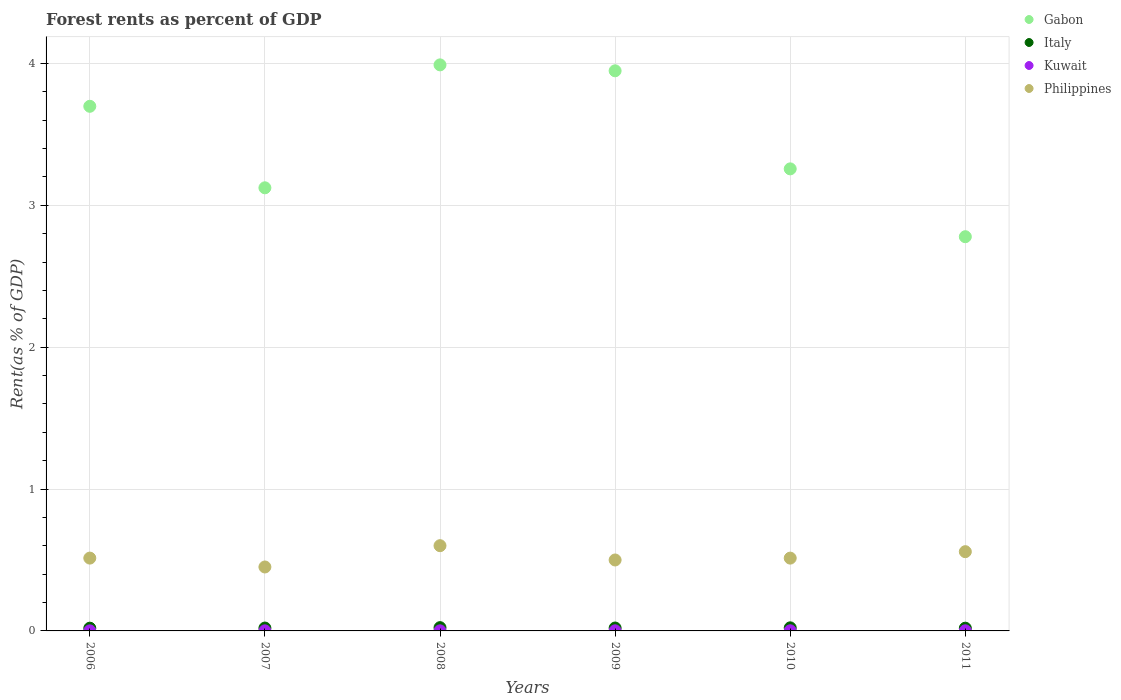Is the number of dotlines equal to the number of legend labels?
Offer a very short reply. Yes. What is the forest rent in Italy in 2010?
Keep it short and to the point. 0.02. Across all years, what is the maximum forest rent in Philippines?
Provide a succinct answer. 0.6. Across all years, what is the minimum forest rent in Kuwait?
Your answer should be compact. 0. What is the total forest rent in Italy in the graph?
Give a very brief answer. 0.12. What is the difference between the forest rent in Gabon in 2008 and that in 2010?
Your answer should be very brief. 0.73. What is the difference between the forest rent in Philippines in 2010 and the forest rent in Italy in 2009?
Offer a very short reply. 0.49. What is the average forest rent in Italy per year?
Provide a succinct answer. 0.02. In the year 2006, what is the difference between the forest rent in Kuwait and forest rent in Philippines?
Offer a very short reply. -0.51. In how many years, is the forest rent in Italy greater than 3 %?
Make the answer very short. 0. What is the ratio of the forest rent in Italy in 2007 to that in 2009?
Ensure brevity in your answer.  0.99. Is the forest rent in Italy in 2006 less than that in 2009?
Give a very brief answer. Yes. Is the difference between the forest rent in Kuwait in 2006 and 2008 greater than the difference between the forest rent in Philippines in 2006 and 2008?
Give a very brief answer. Yes. What is the difference between the highest and the second highest forest rent in Kuwait?
Provide a short and direct response. 0. What is the difference between the highest and the lowest forest rent in Kuwait?
Your answer should be compact. 0. In how many years, is the forest rent in Kuwait greater than the average forest rent in Kuwait taken over all years?
Offer a terse response. 3. Is it the case that in every year, the sum of the forest rent in Philippines and forest rent in Kuwait  is greater than the forest rent in Italy?
Offer a terse response. Yes. How many dotlines are there?
Your response must be concise. 4. What is the title of the graph?
Provide a short and direct response. Forest rents as percent of GDP. Does "Seychelles" appear as one of the legend labels in the graph?
Provide a succinct answer. No. What is the label or title of the X-axis?
Give a very brief answer. Years. What is the label or title of the Y-axis?
Your answer should be very brief. Rent(as % of GDP). What is the Rent(as % of GDP) in Gabon in 2006?
Offer a terse response. 3.7. What is the Rent(as % of GDP) of Italy in 2006?
Give a very brief answer. 0.02. What is the Rent(as % of GDP) in Kuwait in 2006?
Your answer should be very brief. 0. What is the Rent(as % of GDP) of Philippines in 2006?
Keep it short and to the point. 0.51. What is the Rent(as % of GDP) of Gabon in 2007?
Give a very brief answer. 3.12. What is the Rent(as % of GDP) of Italy in 2007?
Keep it short and to the point. 0.02. What is the Rent(as % of GDP) of Kuwait in 2007?
Give a very brief answer. 0. What is the Rent(as % of GDP) of Philippines in 2007?
Offer a very short reply. 0.45. What is the Rent(as % of GDP) in Gabon in 2008?
Offer a very short reply. 3.99. What is the Rent(as % of GDP) of Italy in 2008?
Ensure brevity in your answer.  0.02. What is the Rent(as % of GDP) of Kuwait in 2008?
Your answer should be compact. 0. What is the Rent(as % of GDP) of Philippines in 2008?
Your answer should be compact. 0.6. What is the Rent(as % of GDP) of Gabon in 2009?
Provide a succinct answer. 3.95. What is the Rent(as % of GDP) in Italy in 2009?
Offer a very short reply. 0.02. What is the Rent(as % of GDP) in Kuwait in 2009?
Offer a terse response. 0. What is the Rent(as % of GDP) in Philippines in 2009?
Your answer should be compact. 0.5. What is the Rent(as % of GDP) of Gabon in 2010?
Your answer should be compact. 3.26. What is the Rent(as % of GDP) of Italy in 2010?
Make the answer very short. 0.02. What is the Rent(as % of GDP) in Kuwait in 2010?
Provide a succinct answer. 0. What is the Rent(as % of GDP) of Philippines in 2010?
Ensure brevity in your answer.  0.51. What is the Rent(as % of GDP) in Gabon in 2011?
Provide a short and direct response. 2.78. What is the Rent(as % of GDP) of Italy in 2011?
Keep it short and to the point. 0.02. What is the Rent(as % of GDP) of Kuwait in 2011?
Your answer should be compact. 0. What is the Rent(as % of GDP) of Philippines in 2011?
Provide a succinct answer. 0.56. Across all years, what is the maximum Rent(as % of GDP) of Gabon?
Offer a very short reply. 3.99. Across all years, what is the maximum Rent(as % of GDP) in Italy?
Offer a terse response. 0.02. Across all years, what is the maximum Rent(as % of GDP) in Kuwait?
Your response must be concise. 0. Across all years, what is the maximum Rent(as % of GDP) of Philippines?
Your response must be concise. 0.6. Across all years, what is the minimum Rent(as % of GDP) of Gabon?
Your response must be concise. 2.78. Across all years, what is the minimum Rent(as % of GDP) in Italy?
Provide a succinct answer. 0.02. Across all years, what is the minimum Rent(as % of GDP) in Kuwait?
Offer a very short reply. 0. Across all years, what is the minimum Rent(as % of GDP) of Philippines?
Offer a very short reply. 0.45. What is the total Rent(as % of GDP) in Gabon in the graph?
Keep it short and to the point. 20.8. What is the total Rent(as % of GDP) in Italy in the graph?
Make the answer very short. 0.12. What is the total Rent(as % of GDP) of Kuwait in the graph?
Your answer should be very brief. 0. What is the total Rent(as % of GDP) in Philippines in the graph?
Your answer should be very brief. 3.14. What is the difference between the Rent(as % of GDP) in Gabon in 2006 and that in 2007?
Give a very brief answer. 0.57. What is the difference between the Rent(as % of GDP) in Italy in 2006 and that in 2007?
Provide a short and direct response. -0. What is the difference between the Rent(as % of GDP) in Kuwait in 2006 and that in 2007?
Your answer should be very brief. -0. What is the difference between the Rent(as % of GDP) of Philippines in 2006 and that in 2007?
Provide a succinct answer. 0.06. What is the difference between the Rent(as % of GDP) of Gabon in 2006 and that in 2008?
Make the answer very short. -0.29. What is the difference between the Rent(as % of GDP) of Italy in 2006 and that in 2008?
Make the answer very short. -0. What is the difference between the Rent(as % of GDP) of Kuwait in 2006 and that in 2008?
Offer a very short reply. -0. What is the difference between the Rent(as % of GDP) of Philippines in 2006 and that in 2008?
Your answer should be very brief. -0.09. What is the difference between the Rent(as % of GDP) in Gabon in 2006 and that in 2009?
Provide a short and direct response. -0.25. What is the difference between the Rent(as % of GDP) in Italy in 2006 and that in 2009?
Provide a succinct answer. -0. What is the difference between the Rent(as % of GDP) of Kuwait in 2006 and that in 2009?
Your answer should be compact. -0. What is the difference between the Rent(as % of GDP) of Philippines in 2006 and that in 2009?
Keep it short and to the point. 0.01. What is the difference between the Rent(as % of GDP) in Gabon in 2006 and that in 2010?
Make the answer very short. 0.44. What is the difference between the Rent(as % of GDP) of Italy in 2006 and that in 2010?
Offer a very short reply. -0. What is the difference between the Rent(as % of GDP) of Kuwait in 2006 and that in 2010?
Provide a short and direct response. -0. What is the difference between the Rent(as % of GDP) in Gabon in 2006 and that in 2011?
Ensure brevity in your answer.  0.92. What is the difference between the Rent(as % of GDP) in Kuwait in 2006 and that in 2011?
Offer a terse response. -0. What is the difference between the Rent(as % of GDP) in Philippines in 2006 and that in 2011?
Give a very brief answer. -0.05. What is the difference between the Rent(as % of GDP) in Gabon in 2007 and that in 2008?
Offer a terse response. -0.87. What is the difference between the Rent(as % of GDP) of Italy in 2007 and that in 2008?
Keep it short and to the point. -0. What is the difference between the Rent(as % of GDP) of Philippines in 2007 and that in 2008?
Your response must be concise. -0.15. What is the difference between the Rent(as % of GDP) in Gabon in 2007 and that in 2009?
Provide a short and direct response. -0.82. What is the difference between the Rent(as % of GDP) in Italy in 2007 and that in 2009?
Provide a short and direct response. -0. What is the difference between the Rent(as % of GDP) in Kuwait in 2007 and that in 2009?
Offer a very short reply. -0. What is the difference between the Rent(as % of GDP) of Philippines in 2007 and that in 2009?
Provide a succinct answer. -0.05. What is the difference between the Rent(as % of GDP) of Gabon in 2007 and that in 2010?
Keep it short and to the point. -0.13. What is the difference between the Rent(as % of GDP) of Italy in 2007 and that in 2010?
Provide a succinct answer. -0. What is the difference between the Rent(as % of GDP) of Kuwait in 2007 and that in 2010?
Your answer should be compact. -0. What is the difference between the Rent(as % of GDP) of Philippines in 2007 and that in 2010?
Your answer should be compact. -0.06. What is the difference between the Rent(as % of GDP) in Gabon in 2007 and that in 2011?
Your response must be concise. 0.34. What is the difference between the Rent(as % of GDP) of Italy in 2007 and that in 2011?
Ensure brevity in your answer.  0. What is the difference between the Rent(as % of GDP) of Kuwait in 2007 and that in 2011?
Make the answer very short. -0. What is the difference between the Rent(as % of GDP) of Philippines in 2007 and that in 2011?
Ensure brevity in your answer.  -0.11. What is the difference between the Rent(as % of GDP) of Gabon in 2008 and that in 2009?
Your response must be concise. 0.04. What is the difference between the Rent(as % of GDP) of Italy in 2008 and that in 2009?
Make the answer very short. 0. What is the difference between the Rent(as % of GDP) of Kuwait in 2008 and that in 2009?
Offer a terse response. -0. What is the difference between the Rent(as % of GDP) in Philippines in 2008 and that in 2009?
Your response must be concise. 0.1. What is the difference between the Rent(as % of GDP) of Gabon in 2008 and that in 2010?
Keep it short and to the point. 0.73. What is the difference between the Rent(as % of GDP) in Italy in 2008 and that in 2010?
Give a very brief answer. 0. What is the difference between the Rent(as % of GDP) of Kuwait in 2008 and that in 2010?
Your answer should be very brief. -0. What is the difference between the Rent(as % of GDP) in Philippines in 2008 and that in 2010?
Give a very brief answer. 0.09. What is the difference between the Rent(as % of GDP) in Gabon in 2008 and that in 2011?
Keep it short and to the point. 1.21. What is the difference between the Rent(as % of GDP) in Italy in 2008 and that in 2011?
Your answer should be very brief. 0. What is the difference between the Rent(as % of GDP) in Kuwait in 2008 and that in 2011?
Offer a very short reply. -0. What is the difference between the Rent(as % of GDP) of Philippines in 2008 and that in 2011?
Ensure brevity in your answer.  0.04. What is the difference between the Rent(as % of GDP) in Gabon in 2009 and that in 2010?
Keep it short and to the point. 0.69. What is the difference between the Rent(as % of GDP) in Italy in 2009 and that in 2010?
Your response must be concise. -0. What is the difference between the Rent(as % of GDP) of Kuwait in 2009 and that in 2010?
Offer a terse response. -0. What is the difference between the Rent(as % of GDP) of Philippines in 2009 and that in 2010?
Keep it short and to the point. -0.01. What is the difference between the Rent(as % of GDP) in Gabon in 2009 and that in 2011?
Your response must be concise. 1.17. What is the difference between the Rent(as % of GDP) in Italy in 2009 and that in 2011?
Offer a terse response. 0. What is the difference between the Rent(as % of GDP) in Philippines in 2009 and that in 2011?
Provide a succinct answer. -0.06. What is the difference between the Rent(as % of GDP) in Gabon in 2010 and that in 2011?
Give a very brief answer. 0.48. What is the difference between the Rent(as % of GDP) in Italy in 2010 and that in 2011?
Provide a short and direct response. 0. What is the difference between the Rent(as % of GDP) of Kuwait in 2010 and that in 2011?
Keep it short and to the point. 0. What is the difference between the Rent(as % of GDP) of Philippines in 2010 and that in 2011?
Ensure brevity in your answer.  -0.05. What is the difference between the Rent(as % of GDP) of Gabon in 2006 and the Rent(as % of GDP) of Italy in 2007?
Your response must be concise. 3.68. What is the difference between the Rent(as % of GDP) in Gabon in 2006 and the Rent(as % of GDP) in Kuwait in 2007?
Provide a short and direct response. 3.7. What is the difference between the Rent(as % of GDP) of Gabon in 2006 and the Rent(as % of GDP) of Philippines in 2007?
Your answer should be compact. 3.25. What is the difference between the Rent(as % of GDP) of Italy in 2006 and the Rent(as % of GDP) of Kuwait in 2007?
Provide a short and direct response. 0.02. What is the difference between the Rent(as % of GDP) of Italy in 2006 and the Rent(as % of GDP) of Philippines in 2007?
Offer a terse response. -0.43. What is the difference between the Rent(as % of GDP) of Kuwait in 2006 and the Rent(as % of GDP) of Philippines in 2007?
Your answer should be very brief. -0.45. What is the difference between the Rent(as % of GDP) in Gabon in 2006 and the Rent(as % of GDP) in Italy in 2008?
Provide a short and direct response. 3.68. What is the difference between the Rent(as % of GDP) in Gabon in 2006 and the Rent(as % of GDP) in Kuwait in 2008?
Offer a very short reply. 3.7. What is the difference between the Rent(as % of GDP) in Gabon in 2006 and the Rent(as % of GDP) in Philippines in 2008?
Offer a terse response. 3.1. What is the difference between the Rent(as % of GDP) of Italy in 2006 and the Rent(as % of GDP) of Kuwait in 2008?
Make the answer very short. 0.02. What is the difference between the Rent(as % of GDP) in Italy in 2006 and the Rent(as % of GDP) in Philippines in 2008?
Your answer should be compact. -0.58. What is the difference between the Rent(as % of GDP) in Kuwait in 2006 and the Rent(as % of GDP) in Philippines in 2008?
Provide a succinct answer. -0.6. What is the difference between the Rent(as % of GDP) in Gabon in 2006 and the Rent(as % of GDP) in Italy in 2009?
Make the answer very short. 3.68. What is the difference between the Rent(as % of GDP) of Gabon in 2006 and the Rent(as % of GDP) of Kuwait in 2009?
Give a very brief answer. 3.7. What is the difference between the Rent(as % of GDP) of Gabon in 2006 and the Rent(as % of GDP) of Philippines in 2009?
Provide a succinct answer. 3.2. What is the difference between the Rent(as % of GDP) of Italy in 2006 and the Rent(as % of GDP) of Kuwait in 2009?
Make the answer very short. 0.02. What is the difference between the Rent(as % of GDP) of Italy in 2006 and the Rent(as % of GDP) of Philippines in 2009?
Keep it short and to the point. -0.48. What is the difference between the Rent(as % of GDP) of Kuwait in 2006 and the Rent(as % of GDP) of Philippines in 2009?
Keep it short and to the point. -0.5. What is the difference between the Rent(as % of GDP) in Gabon in 2006 and the Rent(as % of GDP) in Italy in 2010?
Provide a succinct answer. 3.68. What is the difference between the Rent(as % of GDP) in Gabon in 2006 and the Rent(as % of GDP) in Kuwait in 2010?
Your answer should be compact. 3.7. What is the difference between the Rent(as % of GDP) in Gabon in 2006 and the Rent(as % of GDP) in Philippines in 2010?
Offer a very short reply. 3.19. What is the difference between the Rent(as % of GDP) in Italy in 2006 and the Rent(as % of GDP) in Kuwait in 2010?
Give a very brief answer. 0.02. What is the difference between the Rent(as % of GDP) in Italy in 2006 and the Rent(as % of GDP) in Philippines in 2010?
Your answer should be compact. -0.49. What is the difference between the Rent(as % of GDP) of Kuwait in 2006 and the Rent(as % of GDP) of Philippines in 2010?
Keep it short and to the point. -0.51. What is the difference between the Rent(as % of GDP) of Gabon in 2006 and the Rent(as % of GDP) of Italy in 2011?
Ensure brevity in your answer.  3.68. What is the difference between the Rent(as % of GDP) in Gabon in 2006 and the Rent(as % of GDP) in Kuwait in 2011?
Your answer should be compact. 3.7. What is the difference between the Rent(as % of GDP) in Gabon in 2006 and the Rent(as % of GDP) in Philippines in 2011?
Offer a very short reply. 3.14. What is the difference between the Rent(as % of GDP) of Italy in 2006 and the Rent(as % of GDP) of Kuwait in 2011?
Provide a succinct answer. 0.02. What is the difference between the Rent(as % of GDP) of Italy in 2006 and the Rent(as % of GDP) of Philippines in 2011?
Your response must be concise. -0.54. What is the difference between the Rent(as % of GDP) of Kuwait in 2006 and the Rent(as % of GDP) of Philippines in 2011?
Your answer should be very brief. -0.56. What is the difference between the Rent(as % of GDP) of Gabon in 2007 and the Rent(as % of GDP) of Italy in 2008?
Offer a terse response. 3.1. What is the difference between the Rent(as % of GDP) of Gabon in 2007 and the Rent(as % of GDP) of Kuwait in 2008?
Give a very brief answer. 3.12. What is the difference between the Rent(as % of GDP) in Gabon in 2007 and the Rent(as % of GDP) in Philippines in 2008?
Your response must be concise. 2.52. What is the difference between the Rent(as % of GDP) of Italy in 2007 and the Rent(as % of GDP) of Kuwait in 2008?
Your answer should be compact. 0.02. What is the difference between the Rent(as % of GDP) of Italy in 2007 and the Rent(as % of GDP) of Philippines in 2008?
Offer a very short reply. -0.58. What is the difference between the Rent(as % of GDP) in Kuwait in 2007 and the Rent(as % of GDP) in Philippines in 2008?
Ensure brevity in your answer.  -0.6. What is the difference between the Rent(as % of GDP) of Gabon in 2007 and the Rent(as % of GDP) of Italy in 2009?
Make the answer very short. 3.1. What is the difference between the Rent(as % of GDP) of Gabon in 2007 and the Rent(as % of GDP) of Kuwait in 2009?
Give a very brief answer. 3.12. What is the difference between the Rent(as % of GDP) of Gabon in 2007 and the Rent(as % of GDP) of Philippines in 2009?
Ensure brevity in your answer.  2.62. What is the difference between the Rent(as % of GDP) in Italy in 2007 and the Rent(as % of GDP) in Kuwait in 2009?
Provide a succinct answer. 0.02. What is the difference between the Rent(as % of GDP) in Italy in 2007 and the Rent(as % of GDP) in Philippines in 2009?
Offer a very short reply. -0.48. What is the difference between the Rent(as % of GDP) in Kuwait in 2007 and the Rent(as % of GDP) in Philippines in 2009?
Your response must be concise. -0.5. What is the difference between the Rent(as % of GDP) in Gabon in 2007 and the Rent(as % of GDP) in Italy in 2010?
Provide a succinct answer. 3.1. What is the difference between the Rent(as % of GDP) in Gabon in 2007 and the Rent(as % of GDP) in Kuwait in 2010?
Give a very brief answer. 3.12. What is the difference between the Rent(as % of GDP) of Gabon in 2007 and the Rent(as % of GDP) of Philippines in 2010?
Make the answer very short. 2.61. What is the difference between the Rent(as % of GDP) of Italy in 2007 and the Rent(as % of GDP) of Kuwait in 2010?
Provide a short and direct response. 0.02. What is the difference between the Rent(as % of GDP) of Italy in 2007 and the Rent(as % of GDP) of Philippines in 2010?
Offer a terse response. -0.49. What is the difference between the Rent(as % of GDP) in Kuwait in 2007 and the Rent(as % of GDP) in Philippines in 2010?
Offer a very short reply. -0.51. What is the difference between the Rent(as % of GDP) in Gabon in 2007 and the Rent(as % of GDP) in Italy in 2011?
Offer a terse response. 3.1. What is the difference between the Rent(as % of GDP) in Gabon in 2007 and the Rent(as % of GDP) in Kuwait in 2011?
Your answer should be compact. 3.12. What is the difference between the Rent(as % of GDP) in Gabon in 2007 and the Rent(as % of GDP) in Philippines in 2011?
Ensure brevity in your answer.  2.56. What is the difference between the Rent(as % of GDP) of Italy in 2007 and the Rent(as % of GDP) of Kuwait in 2011?
Ensure brevity in your answer.  0.02. What is the difference between the Rent(as % of GDP) in Italy in 2007 and the Rent(as % of GDP) in Philippines in 2011?
Your answer should be compact. -0.54. What is the difference between the Rent(as % of GDP) in Kuwait in 2007 and the Rent(as % of GDP) in Philippines in 2011?
Offer a very short reply. -0.56. What is the difference between the Rent(as % of GDP) in Gabon in 2008 and the Rent(as % of GDP) in Italy in 2009?
Give a very brief answer. 3.97. What is the difference between the Rent(as % of GDP) in Gabon in 2008 and the Rent(as % of GDP) in Kuwait in 2009?
Keep it short and to the point. 3.99. What is the difference between the Rent(as % of GDP) in Gabon in 2008 and the Rent(as % of GDP) in Philippines in 2009?
Keep it short and to the point. 3.49. What is the difference between the Rent(as % of GDP) of Italy in 2008 and the Rent(as % of GDP) of Kuwait in 2009?
Provide a short and direct response. 0.02. What is the difference between the Rent(as % of GDP) in Italy in 2008 and the Rent(as % of GDP) in Philippines in 2009?
Provide a succinct answer. -0.48. What is the difference between the Rent(as % of GDP) of Kuwait in 2008 and the Rent(as % of GDP) of Philippines in 2009?
Your answer should be compact. -0.5. What is the difference between the Rent(as % of GDP) of Gabon in 2008 and the Rent(as % of GDP) of Italy in 2010?
Ensure brevity in your answer.  3.97. What is the difference between the Rent(as % of GDP) in Gabon in 2008 and the Rent(as % of GDP) in Kuwait in 2010?
Give a very brief answer. 3.99. What is the difference between the Rent(as % of GDP) of Gabon in 2008 and the Rent(as % of GDP) of Philippines in 2010?
Give a very brief answer. 3.48. What is the difference between the Rent(as % of GDP) of Italy in 2008 and the Rent(as % of GDP) of Kuwait in 2010?
Offer a terse response. 0.02. What is the difference between the Rent(as % of GDP) of Italy in 2008 and the Rent(as % of GDP) of Philippines in 2010?
Your answer should be compact. -0.49. What is the difference between the Rent(as % of GDP) of Kuwait in 2008 and the Rent(as % of GDP) of Philippines in 2010?
Provide a short and direct response. -0.51. What is the difference between the Rent(as % of GDP) in Gabon in 2008 and the Rent(as % of GDP) in Italy in 2011?
Keep it short and to the point. 3.97. What is the difference between the Rent(as % of GDP) of Gabon in 2008 and the Rent(as % of GDP) of Kuwait in 2011?
Keep it short and to the point. 3.99. What is the difference between the Rent(as % of GDP) of Gabon in 2008 and the Rent(as % of GDP) of Philippines in 2011?
Provide a succinct answer. 3.43. What is the difference between the Rent(as % of GDP) in Italy in 2008 and the Rent(as % of GDP) in Kuwait in 2011?
Keep it short and to the point. 0.02. What is the difference between the Rent(as % of GDP) in Italy in 2008 and the Rent(as % of GDP) in Philippines in 2011?
Your answer should be very brief. -0.54. What is the difference between the Rent(as % of GDP) of Kuwait in 2008 and the Rent(as % of GDP) of Philippines in 2011?
Your response must be concise. -0.56. What is the difference between the Rent(as % of GDP) in Gabon in 2009 and the Rent(as % of GDP) in Italy in 2010?
Make the answer very short. 3.93. What is the difference between the Rent(as % of GDP) in Gabon in 2009 and the Rent(as % of GDP) in Kuwait in 2010?
Your response must be concise. 3.95. What is the difference between the Rent(as % of GDP) of Gabon in 2009 and the Rent(as % of GDP) of Philippines in 2010?
Ensure brevity in your answer.  3.44. What is the difference between the Rent(as % of GDP) of Italy in 2009 and the Rent(as % of GDP) of Kuwait in 2010?
Your response must be concise. 0.02. What is the difference between the Rent(as % of GDP) of Italy in 2009 and the Rent(as % of GDP) of Philippines in 2010?
Offer a terse response. -0.49. What is the difference between the Rent(as % of GDP) in Kuwait in 2009 and the Rent(as % of GDP) in Philippines in 2010?
Your answer should be compact. -0.51. What is the difference between the Rent(as % of GDP) of Gabon in 2009 and the Rent(as % of GDP) of Italy in 2011?
Your response must be concise. 3.93. What is the difference between the Rent(as % of GDP) in Gabon in 2009 and the Rent(as % of GDP) in Kuwait in 2011?
Give a very brief answer. 3.95. What is the difference between the Rent(as % of GDP) of Gabon in 2009 and the Rent(as % of GDP) of Philippines in 2011?
Make the answer very short. 3.39. What is the difference between the Rent(as % of GDP) in Italy in 2009 and the Rent(as % of GDP) in Kuwait in 2011?
Keep it short and to the point. 0.02. What is the difference between the Rent(as % of GDP) in Italy in 2009 and the Rent(as % of GDP) in Philippines in 2011?
Offer a terse response. -0.54. What is the difference between the Rent(as % of GDP) in Kuwait in 2009 and the Rent(as % of GDP) in Philippines in 2011?
Ensure brevity in your answer.  -0.56. What is the difference between the Rent(as % of GDP) of Gabon in 2010 and the Rent(as % of GDP) of Italy in 2011?
Offer a very short reply. 3.24. What is the difference between the Rent(as % of GDP) in Gabon in 2010 and the Rent(as % of GDP) in Kuwait in 2011?
Ensure brevity in your answer.  3.26. What is the difference between the Rent(as % of GDP) in Gabon in 2010 and the Rent(as % of GDP) in Philippines in 2011?
Keep it short and to the point. 2.7. What is the difference between the Rent(as % of GDP) of Italy in 2010 and the Rent(as % of GDP) of Kuwait in 2011?
Your answer should be very brief. 0.02. What is the difference between the Rent(as % of GDP) of Italy in 2010 and the Rent(as % of GDP) of Philippines in 2011?
Provide a short and direct response. -0.54. What is the difference between the Rent(as % of GDP) of Kuwait in 2010 and the Rent(as % of GDP) of Philippines in 2011?
Offer a very short reply. -0.56. What is the average Rent(as % of GDP) of Gabon per year?
Ensure brevity in your answer.  3.47. What is the average Rent(as % of GDP) in Italy per year?
Give a very brief answer. 0.02. What is the average Rent(as % of GDP) of Kuwait per year?
Offer a terse response. 0. What is the average Rent(as % of GDP) in Philippines per year?
Provide a succinct answer. 0.52. In the year 2006, what is the difference between the Rent(as % of GDP) in Gabon and Rent(as % of GDP) in Italy?
Give a very brief answer. 3.68. In the year 2006, what is the difference between the Rent(as % of GDP) in Gabon and Rent(as % of GDP) in Kuwait?
Keep it short and to the point. 3.7. In the year 2006, what is the difference between the Rent(as % of GDP) of Gabon and Rent(as % of GDP) of Philippines?
Your response must be concise. 3.18. In the year 2006, what is the difference between the Rent(as % of GDP) of Italy and Rent(as % of GDP) of Kuwait?
Your answer should be compact. 0.02. In the year 2006, what is the difference between the Rent(as % of GDP) in Italy and Rent(as % of GDP) in Philippines?
Keep it short and to the point. -0.49. In the year 2006, what is the difference between the Rent(as % of GDP) of Kuwait and Rent(as % of GDP) of Philippines?
Offer a terse response. -0.51. In the year 2007, what is the difference between the Rent(as % of GDP) in Gabon and Rent(as % of GDP) in Italy?
Offer a very short reply. 3.1. In the year 2007, what is the difference between the Rent(as % of GDP) in Gabon and Rent(as % of GDP) in Kuwait?
Your response must be concise. 3.12. In the year 2007, what is the difference between the Rent(as % of GDP) of Gabon and Rent(as % of GDP) of Philippines?
Ensure brevity in your answer.  2.67. In the year 2007, what is the difference between the Rent(as % of GDP) of Italy and Rent(as % of GDP) of Kuwait?
Your response must be concise. 0.02. In the year 2007, what is the difference between the Rent(as % of GDP) of Italy and Rent(as % of GDP) of Philippines?
Make the answer very short. -0.43. In the year 2007, what is the difference between the Rent(as % of GDP) in Kuwait and Rent(as % of GDP) in Philippines?
Your answer should be compact. -0.45. In the year 2008, what is the difference between the Rent(as % of GDP) in Gabon and Rent(as % of GDP) in Italy?
Provide a succinct answer. 3.97. In the year 2008, what is the difference between the Rent(as % of GDP) of Gabon and Rent(as % of GDP) of Kuwait?
Offer a terse response. 3.99. In the year 2008, what is the difference between the Rent(as % of GDP) of Gabon and Rent(as % of GDP) of Philippines?
Offer a terse response. 3.39. In the year 2008, what is the difference between the Rent(as % of GDP) of Italy and Rent(as % of GDP) of Kuwait?
Your answer should be very brief. 0.02. In the year 2008, what is the difference between the Rent(as % of GDP) of Italy and Rent(as % of GDP) of Philippines?
Make the answer very short. -0.58. In the year 2008, what is the difference between the Rent(as % of GDP) in Kuwait and Rent(as % of GDP) in Philippines?
Offer a terse response. -0.6. In the year 2009, what is the difference between the Rent(as % of GDP) of Gabon and Rent(as % of GDP) of Italy?
Your response must be concise. 3.93. In the year 2009, what is the difference between the Rent(as % of GDP) of Gabon and Rent(as % of GDP) of Kuwait?
Keep it short and to the point. 3.95. In the year 2009, what is the difference between the Rent(as % of GDP) in Gabon and Rent(as % of GDP) in Philippines?
Your response must be concise. 3.45. In the year 2009, what is the difference between the Rent(as % of GDP) in Italy and Rent(as % of GDP) in Kuwait?
Give a very brief answer. 0.02. In the year 2009, what is the difference between the Rent(as % of GDP) of Italy and Rent(as % of GDP) of Philippines?
Your answer should be compact. -0.48. In the year 2009, what is the difference between the Rent(as % of GDP) in Kuwait and Rent(as % of GDP) in Philippines?
Offer a terse response. -0.5. In the year 2010, what is the difference between the Rent(as % of GDP) in Gabon and Rent(as % of GDP) in Italy?
Offer a terse response. 3.24. In the year 2010, what is the difference between the Rent(as % of GDP) in Gabon and Rent(as % of GDP) in Kuwait?
Provide a succinct answer. 3.26. In the year 2010, what is the difference between the Rent(as % of GDP) in Gabon and Rent(as % of GDP) in Philippines?
Make the answer very short. 2.74. In the year 2010, what is the difference between the Rent(as % of GDP) of Italy and Rent(as % of GDP) of Kuwait?
Make the answer very short. 0.02. In the year 2010, what is the difference between the Rent(as % of GDP) in Italy and Rent(as % of GDP) in Philippines?
Your answer should be very brief. -0.49. In the year 2010, what is the difference between the Rent(as % of GDP) of Kuwait and Rent(as % of GDP) of Philippines?
Offer a terse response. -0.51. In the year 2011, what is the difference between the Rent(as % of GDP) of Gabon and Rent(as % of GDP) of Italy?
Keep it short and to the point. 2.76. In the year 2011, what is the difference between the Rent(as % of GDP) of Gabon and Rent(as % of GDP) of Kuwait?
Ensure brevity in your answer.  2.78. In the year 2011, what is the difference between the Rent(as % of GDP) in Gabon and Rent(as % of GDP) in Philippines?
Your answer should be very brief. 2.22. In the year 2011, what is the difference between the Rent(as % of GDP) in Italy and Rent(as % of GDP) in Kuwait?
Offer a terse response. 0.02. In the year 2011, what is the difference between the Rent(as % of GDP) of Italy and Rent(as % of GDP) of Philippines?
Ensure brevity in your answer.  -0.54. In the year 2011, what is the difference between the Rent(as % of GDP) in Kuwait and Rent(as % of GDP) in Philippines?
Offer a terse response. -0.56. What is the ratio of the Rent(as % of GDP) in Gabon in 2006 to that in 2007?
Provide a succinct answer. 1.18. What is the ratio of the Rent(as % of GDP) in Italy in 2006 to that in 2007?
Provide a short and direct response. 0.95. What is the ratio of the Rent(as % of GDP) in Kuwait in 2006 to that in 2007?
Make the answer very short. 0.81. What is the ratio of the Rent(as % of GDP) in Philippines in 2006 to that in 2007?
Your answer should be compact. 1.14. What is the ratio of the Rent(as % of GDP) of Gabon in 2006 to that in 2008?
Offer a very short reply. 0.93. What is the ratio of the Rent(as % of GDP) of Italy in 2006 to that in 2008?
Offer a very short reply. 0.84. What is the ratio of the Rent(as % of GDP) in Kuwait in 2006 to that in 2008?
Offer a very short reply. 0.74. What is the ratio of the Rent(as % of GDP) in Philippines in 2006 to that in 2008?
Provide a short and direct response. 0.85. What is the ratio of the Rent(as % of GDP) in Gabon in 2006 to that in 2009?
Give a very brief answer. 0.94. What is the ratio of the Rent(as % of GDP) of Italy in 2006 to that in 2009?
Your response must be concise. 0.94. What is the ratio of the Rent(as % of GDP) in Kuwait in 2006 to that in 2009?
Your answer should be very brief. 0.56. What is the ratio of the Rent(as % of GDP) in Philippines in 2006 to that in 2009?
Keep it short and to the point. 1.03. What is the ratio of the Rent(as % of GDP) in Gabon in 2006 to that in 2010?
Ensure brevity in your answer.  1.14. What is the ratio of the Rent(as % of GDP) of Italy in 2006 to that in 2010?
Your answer should be compact. 0.89. What is the ratio of the Rent(as % of GDP) in Kuwait in 2006 to that in 2010?
Your answer should be very brief. 0.48. What is the ratio of the Rent(as % of GDP) of Philippines in 2006 to that in 2010?
Keep it short and to the point. 1. What is the ratio of the Rent(as % of GDP) of Gabon in 2006 to that in 2011?
Provide a succinct answer. 1.33. What is the ratio of the Rent(as % of GDP) of Italy in 2006 to that in 2011?
Give a very brief answer. 1. What is the ratio of the Rent(as % of GDP) in Kuwait in 2006 to that in 2011?
Give a very brief answer. 0.54. What is the ratio of the Rent(as % of GDP) in Philippines in 2006 to that in 2011?
Provide a short and direct response. 0.92. What is the ratio of the Rent(as % of GDP) in Gabon in 2007 to that in 2008?
Offer a very short reply. 0.78. What is the ratio of the Rent(as % of GDP) of Italy in 2007 to that in 2008?
Give a very brief answer. 0.88. What is the ratio of the Rent(as % of GDP) of Kuwait in 2007 to that in 2008?
Offer a very short reply. 0.92. What is the ratio of the Rent(as % of GDP) in Philippines in 2007 to that in 2008?
Offer a terse response. 0.75. What is the ratio of the Rent(as % of GDP) in Gabon in 2007 to that in 2009?
Keep it short and to the point. 0.79. What is the ratio of the Rent(as % of GDP) of Kuwait in 2007 to that in 2009?
Provide a short and direct response. 0.7. What is the ratio of the Rent(as % of GDP) of Philippines in 2007 to that in 2009?
Make the answer very short. 0.9. What is the ratio of the Rent(as % of GDP) in Italy in 2007 to that in 2010?
Give a very brief answer. 0.93. What is the ratio of the Rent(as % of GDP) in Kuwait in 2007 to that in 2010?
Provide a short and direct response. 0.59. What is the ratio of the Rent(as % of GDP) of Philippines in 2007 to that in 2010?
Offer a terse response. 0.88. What is the ratio of the Rent(as % of GDP) in Gabon in 2007 to that in 2011?
Your response must be concise. 1.12. What is the ratio of the Rent(as % of GDP) of Italy in 2007 to that in 2011?
Make the answer very short. 1.05. What is the ratio of the Rent(as % of GDP) in Kuwait in 2007 to that in 2011?
Keep it short and to the point. 0.68. What is the ratio of the Rent(as % of GDP) in Philippines in 2007 to that in 2011?
Keep it short and to the point. 0.81. What is the ratio of the Rent(as % of GDP) of Gabon in 2008 to that in 2009?
Give a very brief answer. 1.01. What is the ratio of the Rent(as % of GDP) of Italy in 2008 to that in 2009?
Offer a very short reply. 1.13. What is the ratio of the Rent(as % of GDP) of Kuwait in 2008 to that in 2009?
Your answer should be compact. 0.76. What is the ratio of the Rent(as % of GDP) of Philippines in 2008 to that in 2009?
Ensure brevity in your answer.  1.2. What is the ratio of the Rent(as % of GDP) of Gabon in 2008 to that in 2010?
Provide a short and direct response. 1.23. What is the ratio of the Rent(as % of GDP) in Italy in 2008 to that in 2010?
Your answer should be compact. 1.06. What is the ratio of the Rent(as % of GDP) in Kuwait in 2008 to that in 2010?
Give a very brief answer. 0.64. What is the ratio of the Rent(as % of GDP) in Philippines in 2008 to that in 2010?
Offer a very short reply. 1.17. What is the ratio of the Rent(as % of GDP) in Gabon in 2008 to that in 2011?
Offer a terse response. 1.44. What is the ratio of the Rent(as % of GDP) in Italy in 2008 to that in 2011?
Your response must be concise. 1.19. What is the ratio of the Rent(as % of GDP) of Kuwait in 2008 to that in 2011?
Your answer should be compact. 0.73. What is the ratio of the Rent(as % of GDP) in Philippines in 2008 to that in 2011?
Provide a short and direct response. 1.08. What is the ratio of the Rent(as % of GDP) in Gabon in 2009 to that in 2010?
Your response must be concise. 1.21. What is the ratio of the Rent(as % of GDP) in Italy in 2009 to that in 2010?
Your response must be concise. 0.94. What is the ratio of the Rent(as % of GDP) of Kuwait in 2009 to that in 2010?
Provide a succinct answer. 0.85. What is the ratio of the Rent(as % of GDP) in Philippines in 2009 to that in 2010?
Your response must be concise. 0.97. What is the ratio of the Rent(as % of GDP) of Gabon in 2009 to that in 2011?
Your answer should be compact. 1.42. What is the ratio of the Rent(as % of GDP) of Italy in 2009 to that in 2011?
Your answer should be very brief. 1.06. What is the ratio of the Rent(as % of GDP) in Kuwait in 2009 to that in 2011?
Offer a terse response. 0.97. What is the ratio of the Rent(as % of GDP) of Philippines in 2009 to that in 2011?
Ensure brevity in your answer.  0.9. What is the ratio of the Rent(as % of GDP) in Gabon in 2010 to that in 2011?
Your answer should be compact. 1.17. What is the ratio of the Rent(as % of GDP) in Italy in 2010 to that in 2011?
Offer a very short reply. 1.12. What is the ratio of the Rent(as % of GDP) of Kuwait in 2010 to that in 2011?
Your response must be concise. 1.14. What is the ratio of the Rent(as % of GDP) of Philippines in 2010 to that in 2011?
Keep it short and to the point. 0.92. What is the difference between the highest and the second highest Rent(as % of GDP) in Gabon?
Your answer should be very brief. 0.04. What is the difference between the highest and the second highest Rent(as % of GDP) in Italy?
Your answer should be compact. 0. What is the difference between the highest and the second highest Rent(as % of GDP) of Kuwait?
Provide a short and direct response. 0. What is the difference between the highest and the second highest Rent(as % of GDP) in Philippines?
Provide a succinct answer. 0.04. What is the difference between the highest and the lowest Rent(as % of GDP) in Gabon?
Give a very brief answer. 1.21. What is the difference between the highest and the lowest Rent(as % of GDP) in Italy?
Your response must be concise. 0. What is the difference between the highest and the lowest Rent(as % of GDP) of Kuwait?
Your answer should be very brief. 0. What is the difference between the highest and the lowest Rent(as % of GDP) of Philippines?
Offer a terse response. 0.15. 